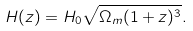<formula> <loc_0><loc_0><loc_500><loc_500>H ( z ) = H _ { 0 } \sqrt { \Omega _ { m } ( 1 + z ) ^ { 3 } } .</formula> 